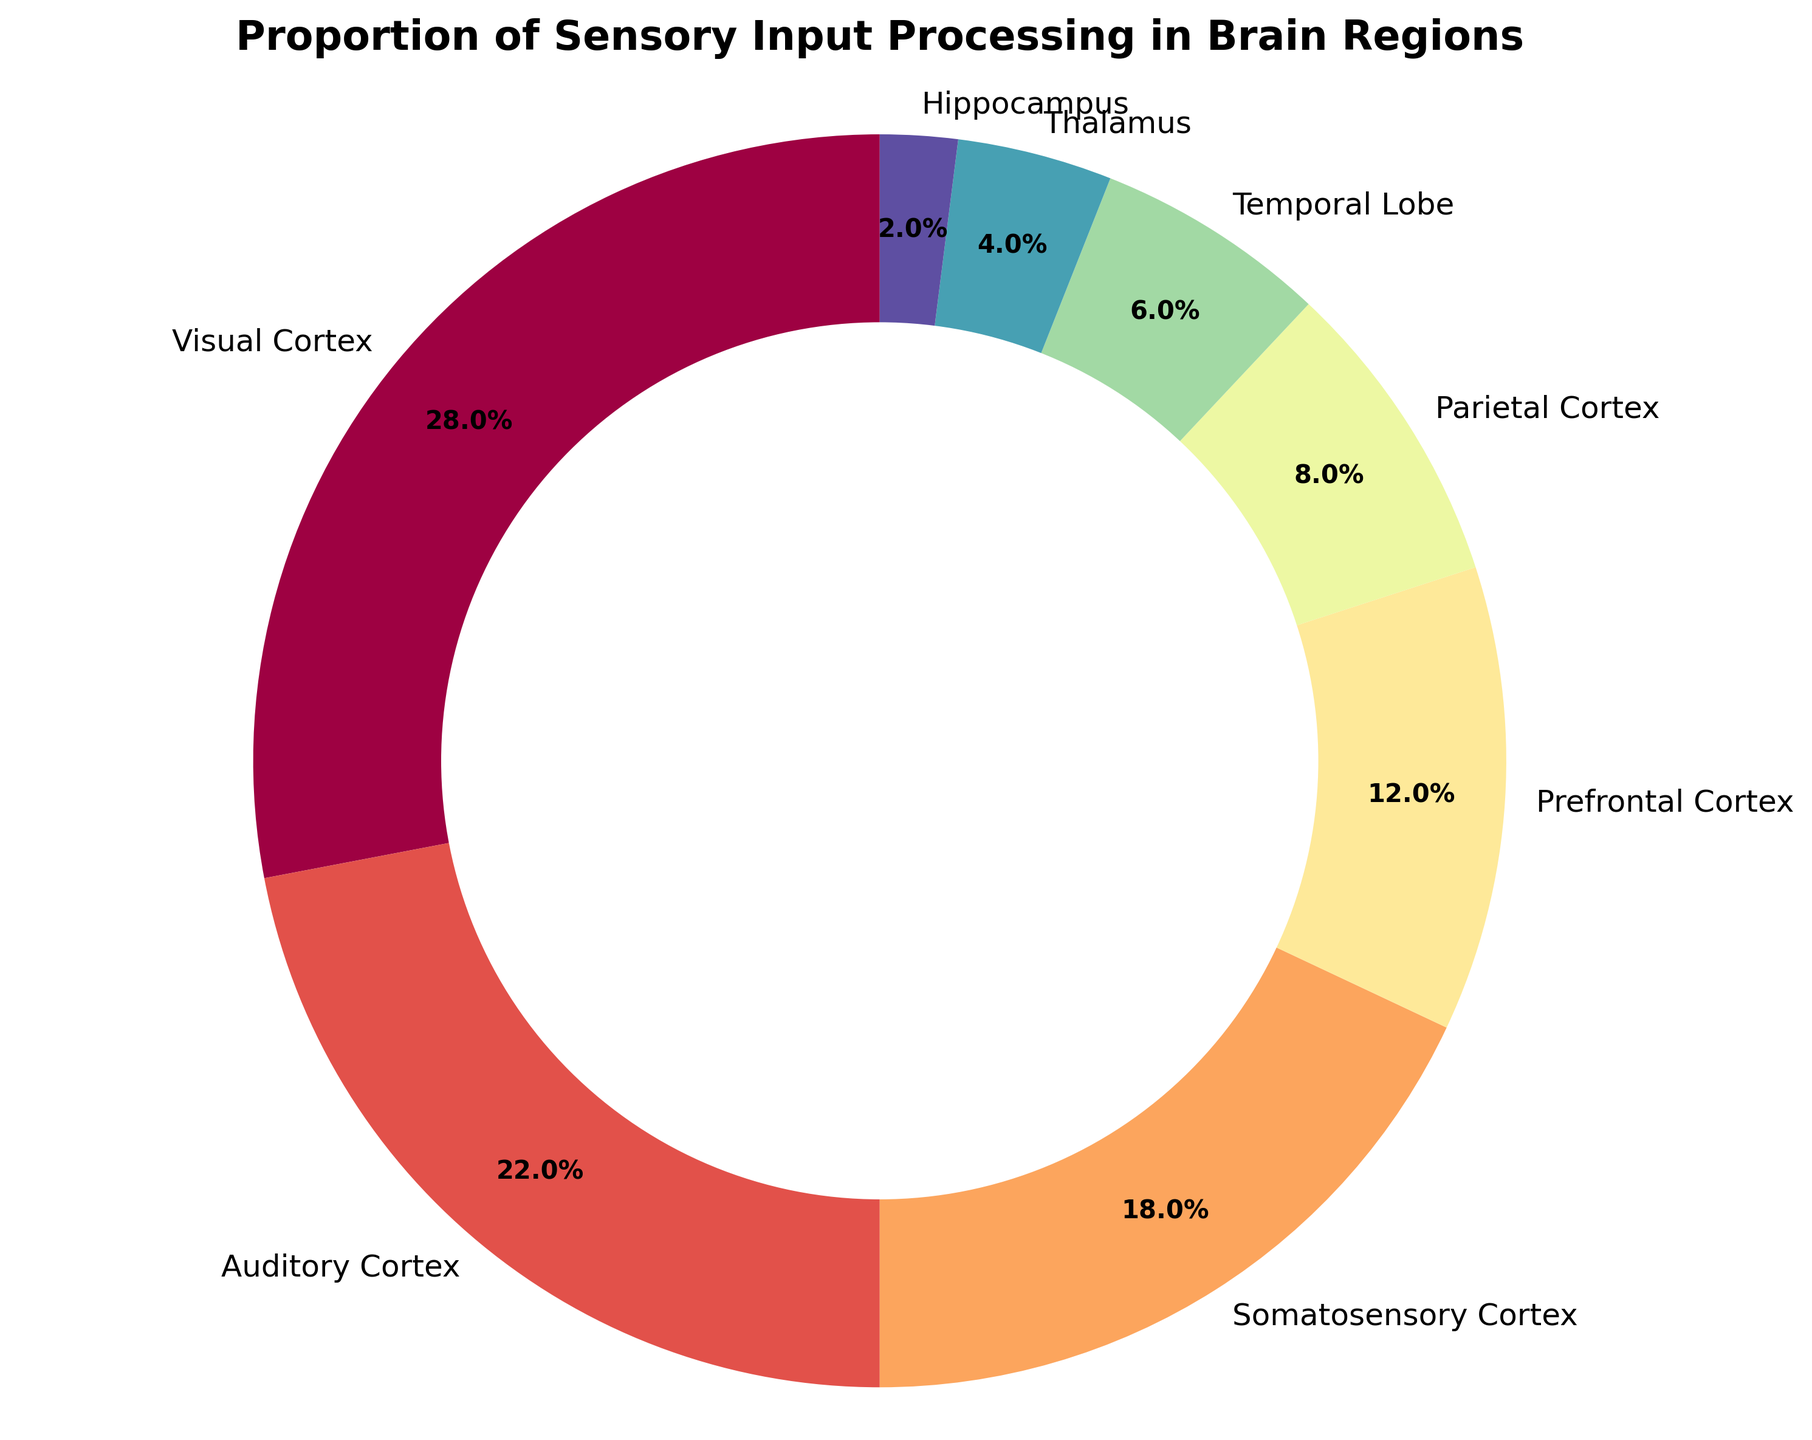What's the combined percentage of sensory input processing in the Visual Cortex and Auditory Cortex? To find the combined percentage, we add the percentages for both the Visual Cortex and the Auditory Cortex. Visual Cortex has 28% and Auditory Cortex has 22%. 28% + 22% = 50%.
Answer: 50% Which two brain regions have the smallest percentages of sensory input processing? In the pie chart, the smallest slices correspond to the smallest percentages. The Hippocampus has 2% and the Thalamus has 4%, making them the two regions with the smallest percentages.
Answer: Hippocampus and Thalamus What is the difference in the proportion of sensory input processing between the Prefrontal Cortex and the Parietal Cortex? We subtract the percentage of the Parietal Cortex from the percentage of the Prefrontal Cortex. Prefrontal Cortex is 12% and Parietal Cortex is 8%. 12% - 8% = 4%.
Answer: 4% Between the Somatosensory Cortex and the Temporal Lobe, which region processes a greater proportion of sensory input? By comparing the percentages, Somatosensory Cortex has 18% while Temporal Lobe has 6%. Hence, the Somatosensory Cortex processes a greater proportion of sensory input.
Answer: Somatosensory Cortex Identify the brain region with a dark red color and provide its percentage of sensory input processing. Observing the pie chart, the brain region with the dark red color corresponds to the Visual Cortex. The Visual Cortex is labeled with a percentage of 28%.
Answer: Visual Cortex, 28% How much more sensory input does the Auditory Cortex process compared to the Temporal Lobe? We subtract the percentage of the Temporal Lobe from the percentage of the Auditory Cortex. Auditory Cortex has 22%, Temporal Lobe has 6%. 22% - 6% = 16%.
Answer: 16% What percentage of sensory input processing is handled collectively by the Prefrontal Cortex, Parietal Cortex, Temporal Lobe, and Thalamus? Summing up the percentages of these regions: Prefrontal Cortex (12%) + Parietal Cortex (8%) + Temporal Lobe (6%) + Thalamus (4%) = 30%.
Answer: 30% Which brain region processes sensory input at a rate that is exactly double that of the Parietal Cortex? Checking the percentages, the Parietal Cortex processes 8%, and the Prefrontal Cortex processes 16% which is exactly double the amount (Parietal Cortex 8% * 2 = 16%).
Answer: Prefrontal Cortex 